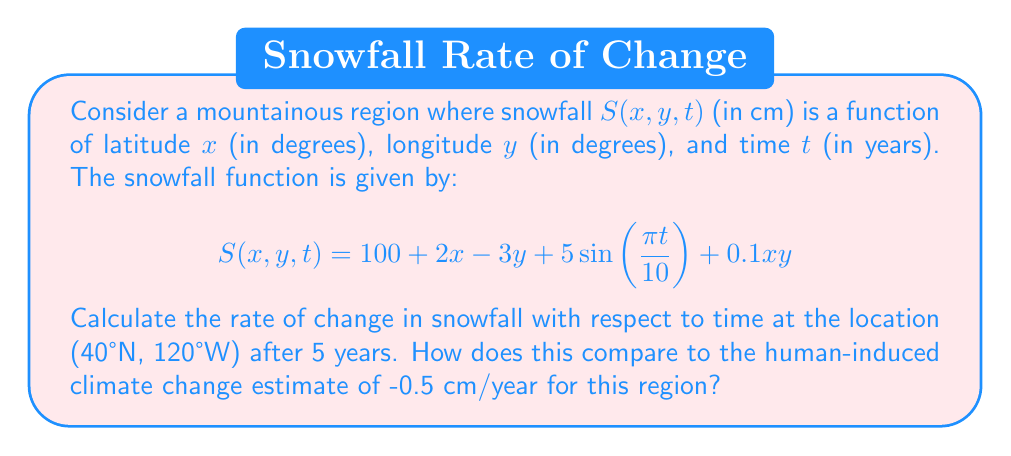Provide a solution to this math problem. To solve this problem, we need to find the partial derivative of $S$ with respect to $t$ and evaluate it at the given point. This will give us the rate of change of snowfall with respect to time.

1. First, let's find $\frac{\partial S}{\partial t}$:

   $$\frac{\partial S}{\partial t} = 5\cdot\frac{\pi}{10}\cos(\frac{\pi t}{10}) = \frac{\pi}{2}\cos(\frac{\pi t}{10})$$

2. Now, we need to evaluate this at $t = 5$ years and the location (40°N, 120°W):

   $$\frac{\partial S}{\partial t}(40, -120, 5) = \frac{\pi}{2}\cos(\frac{\pi \cdot 5}{10}) = \frac{\pi}{2}\cos(\frac{\pi}{2}) = 0$$

3. The rate of change at this specific point and time is 0 cm/year.

4. Comparing this to the human-induced climate change estimate of -0.5 cm/year:

   The natural variability at this point shows no change in snowfall, while the human-induced estimate suggests a decrease of 0.5 cm/year. This supports the argument that natural variability can be a significant factor in snowfall patterns, potentially masking or amplifying human-induced changes.

5. To further support the natural variability argument, we can look at the total variation in snowfall due to the natural cycle:

   The amplitude of the natural cycle is 5 cm, with a period of 20 years. This means that over a 10-year span, the natural variability can account for a change of up to 10 cm in snowfall, which is much larger than the 5 cm change over 10 years suggested by the human-induced estimate.
Answer: The rate of change in snowfall with respect to time at (40°N, 120°W) after 5 years is 0 cm/year. This natural variability result differs from the human-induced climate change estimate of -0.5 cm/year, supporting the argument that natural climate variability can be a significant factor in snowfall changes. 